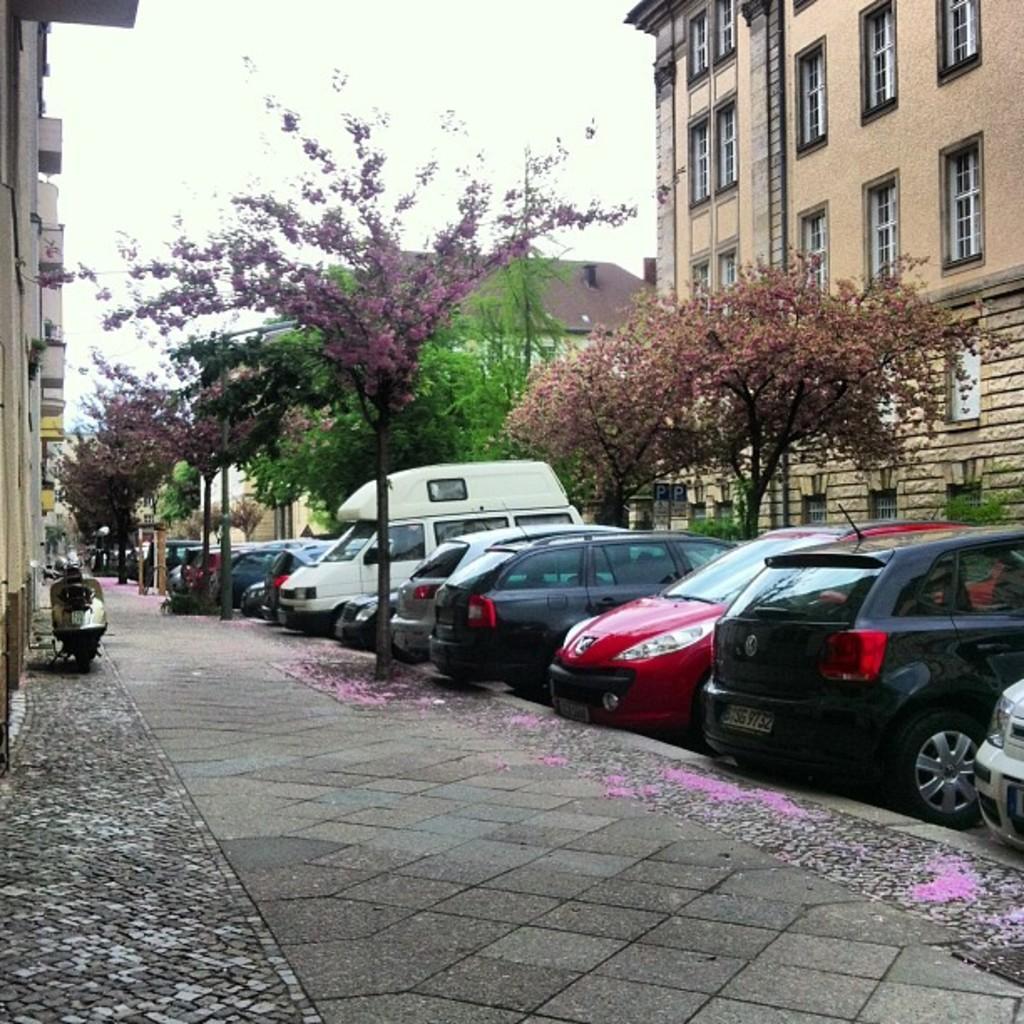In one or two sentences, can you explain what this image depicts? In this image we can see a pavement. To the left side of the image buildings are there and one scooter is parked. To the right side of the image cars are parked, trees are present and buildings are there. 